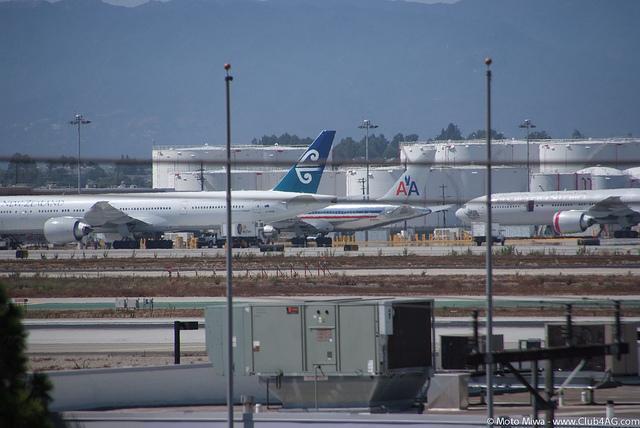How many planes are there?
Give a very brief answer. 3. How many buses are there?
Give a very brief answer. 0. How many airplanes are in the picture?
Give a very brief answer. 2. How many cars are behind the boy?
Give a very brief answer. 0. 